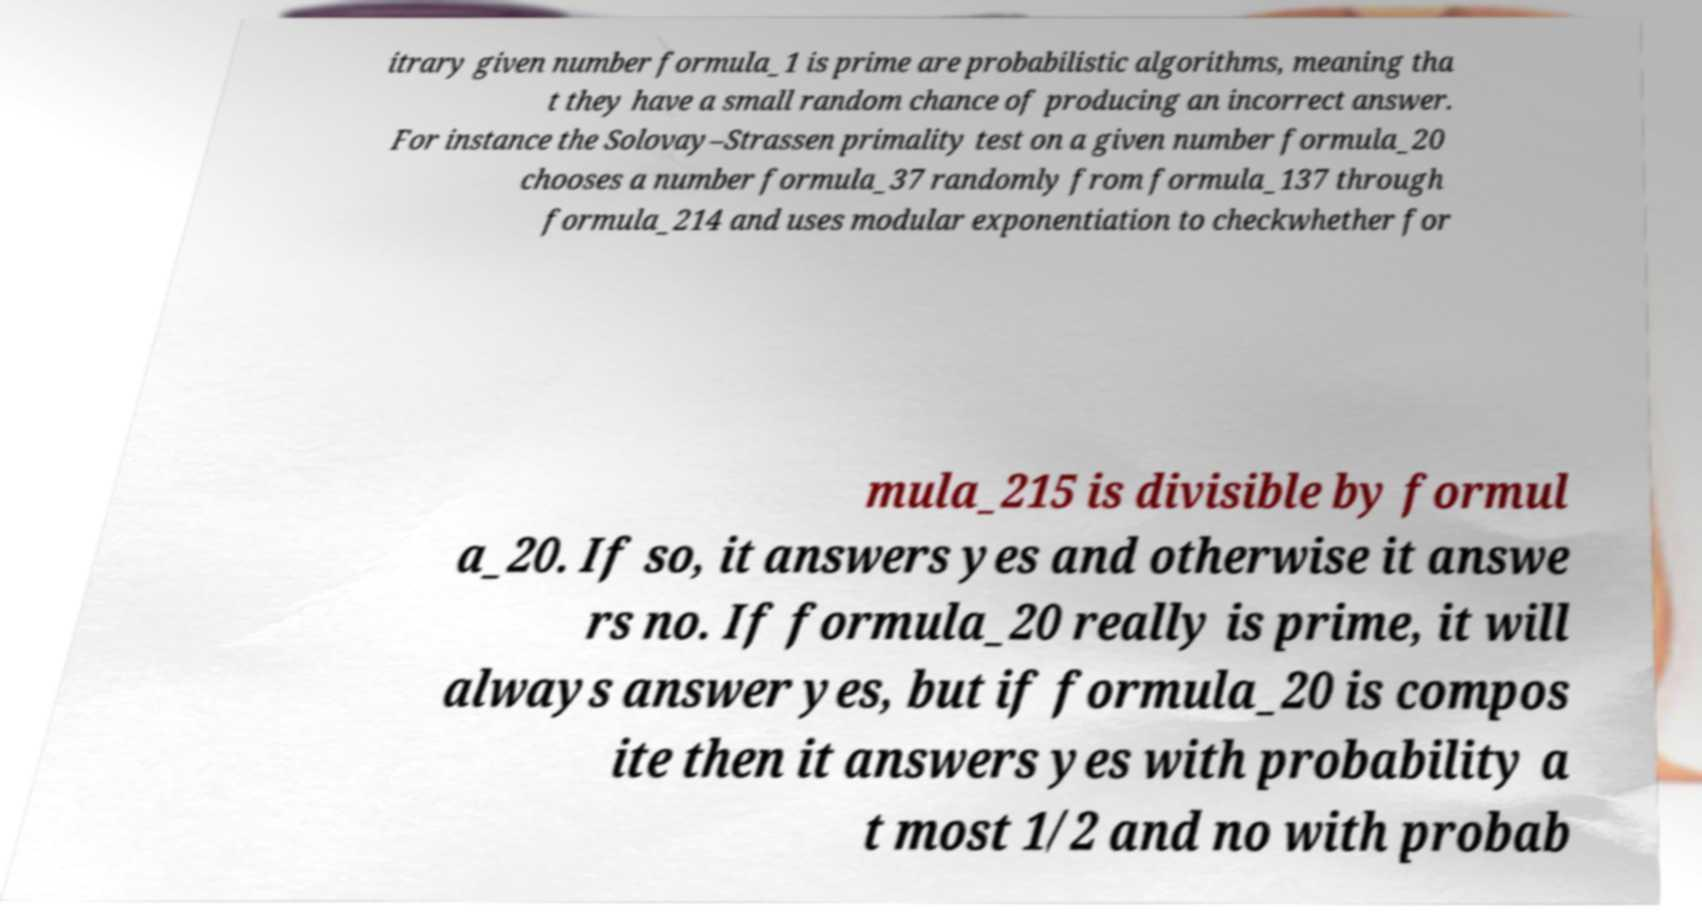There's text embedded in this image that I need extracted. Can you transcribe it verbatim? itrary given number formula_1 is prime are probabilistic algorithms, meaning tha t they have a small random chance of producing an incorrect answer. For instance the Solovay–Strassen primality test on a given number formula_20 chooses a number formula_37 randomly from formula_137 through formula_214 and uses modular exponentiation to checkwhether for mula_215 is divisible by formul a_20. If so, it answers yes and otherwise it answe rs no. If formula_20 really is prime, it will always answer yes, but if formula_20 is compos ite then it answers yes with probability a t most 1/2 and no with probab 